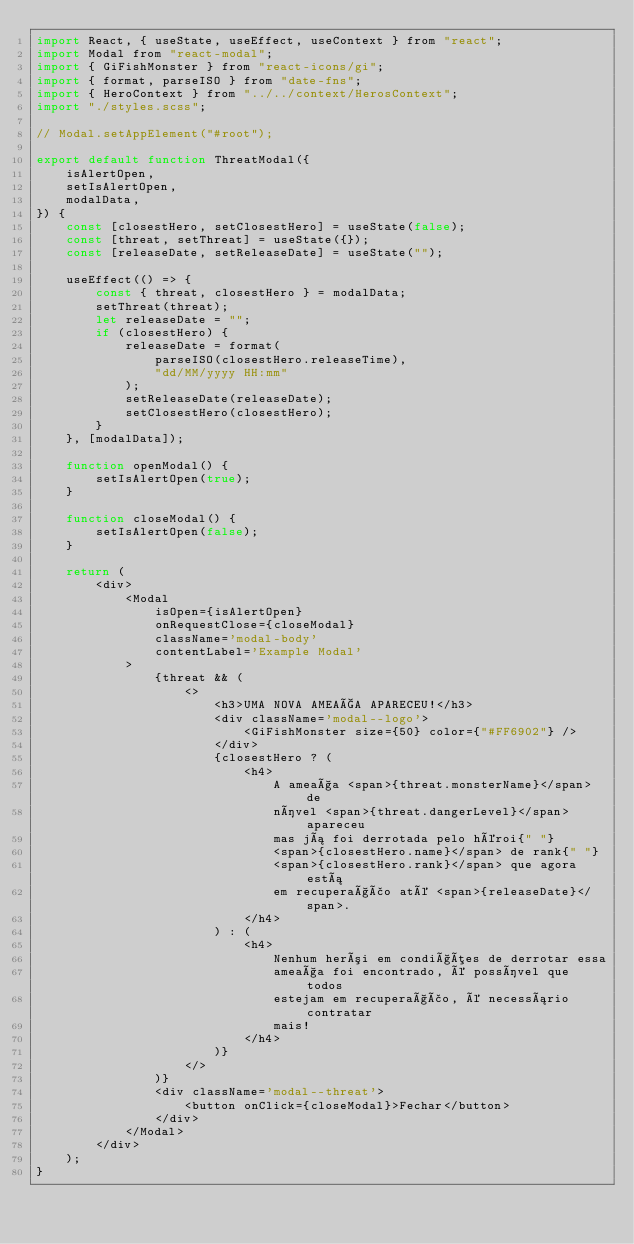<code> <loc_0><loc_0><loc_500><loc_500><_JavaScript_>import React, { useState, useEffect, useContext } from "react";
import Modal from "react-modal";
import { GiFishMonster } from "react-icons/gi";
import { format, parseISO } from "date-fns";
import { HeroContext } from "../../context/HerosContext";
import "./styles.scss";

// Modal.setAppElement("#root");

export default function ThreatModal({
    isAlertOpen,
    setIsAlertOpen,
    modalData,
}) {
    const [closestHero, setClosestHero] = useState(false);
    const [threat, setThreat] = useState({});
    const [releaseDate, setReleaseDate] = useState("");

    useEffect(() => {
        const { threat, closestHero } = modalData;
        setThreat(threat);
        let releaseDate = "";
        if (closestHero) {
            releaseDate = format(
                parseISO(closestHero.releaseTime),
                "dd/MM/yyyy HH:mm"
            );
            setReleaseDate(releaseDate);
            setClosestHero(closestHero);
        }
    }, [modalData]);

    function openModal() {
        setIsAlertOpen(true);
    }

    function closeModal() {
        setIsAlertOpen(false);
    }

    return (
        <div>
            <Modal
                isOpen={isAlertOpen}
                onRequestClose={closeModal}
                className='modal-body'
                contentLabel='Example Modal'
            >
                {threat && (
                    <>
                        <h3>UMA NOVA AMEAÇA APARECEU!</h3>
                        <div className='modal--logo'>
                            <GiFishMonster size={50} color={"#FF6902"} />
                        </div>
                        {closestHero ? (
                            <h4>
                                A ameaça <span>{threat.monsterName}</span> de
                                nível <span>{threat.dangerLevel}</span> apareceu
                                mas já foi derrotada pelo héroi{" "}
                                <span>{closestHero.name}</span> de rank{" "}
                                <span>{closestHero.rank}</span> que agora está
                                em recuperação até <span>{releaseDate}</span>.
                            </h4>
                        ) : (
                            <h4>
                                Nenhum herói em condições de derrotar essa
                                ameaça foi encontrado, é possível que todos
                                estejam em recuperação, é necessário contratar
                                mais!
                            </h4>
                        )}
                    </>
                )}
                <div className='modal--threat'>
                    <button onClick={closeModal}>Fechar</button>
                </div>
            </Modal>
        </div>
    );
}
</code> 